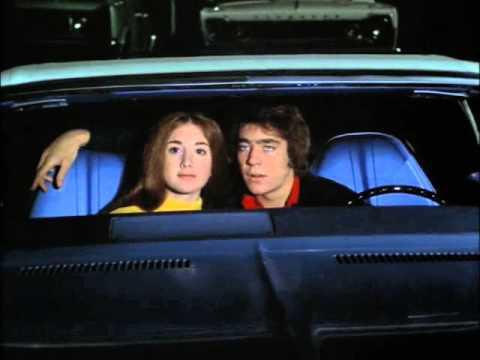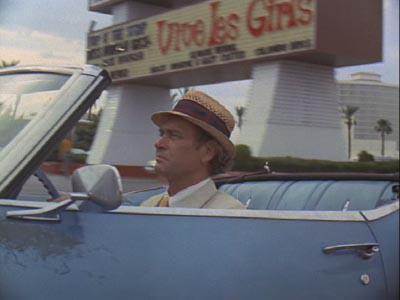The first image is the image on the left, the second image is the image on the right. Given the left and right images, does the statement "Two people are sitting in a car in at least one of the images." hold true? Answer yes or no. Yes. The first image is the image on the left, the second image is the image on the right. For the images displayed, is the sentence "Both images have a brown wooden fence in the background." factually correct? Answer yes or no. No. 